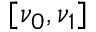<formula> <loc_0><loc_0><loc_500><loc_500>[ \nu _ { 0 } , \nu _ { 1 } ]</formula> 